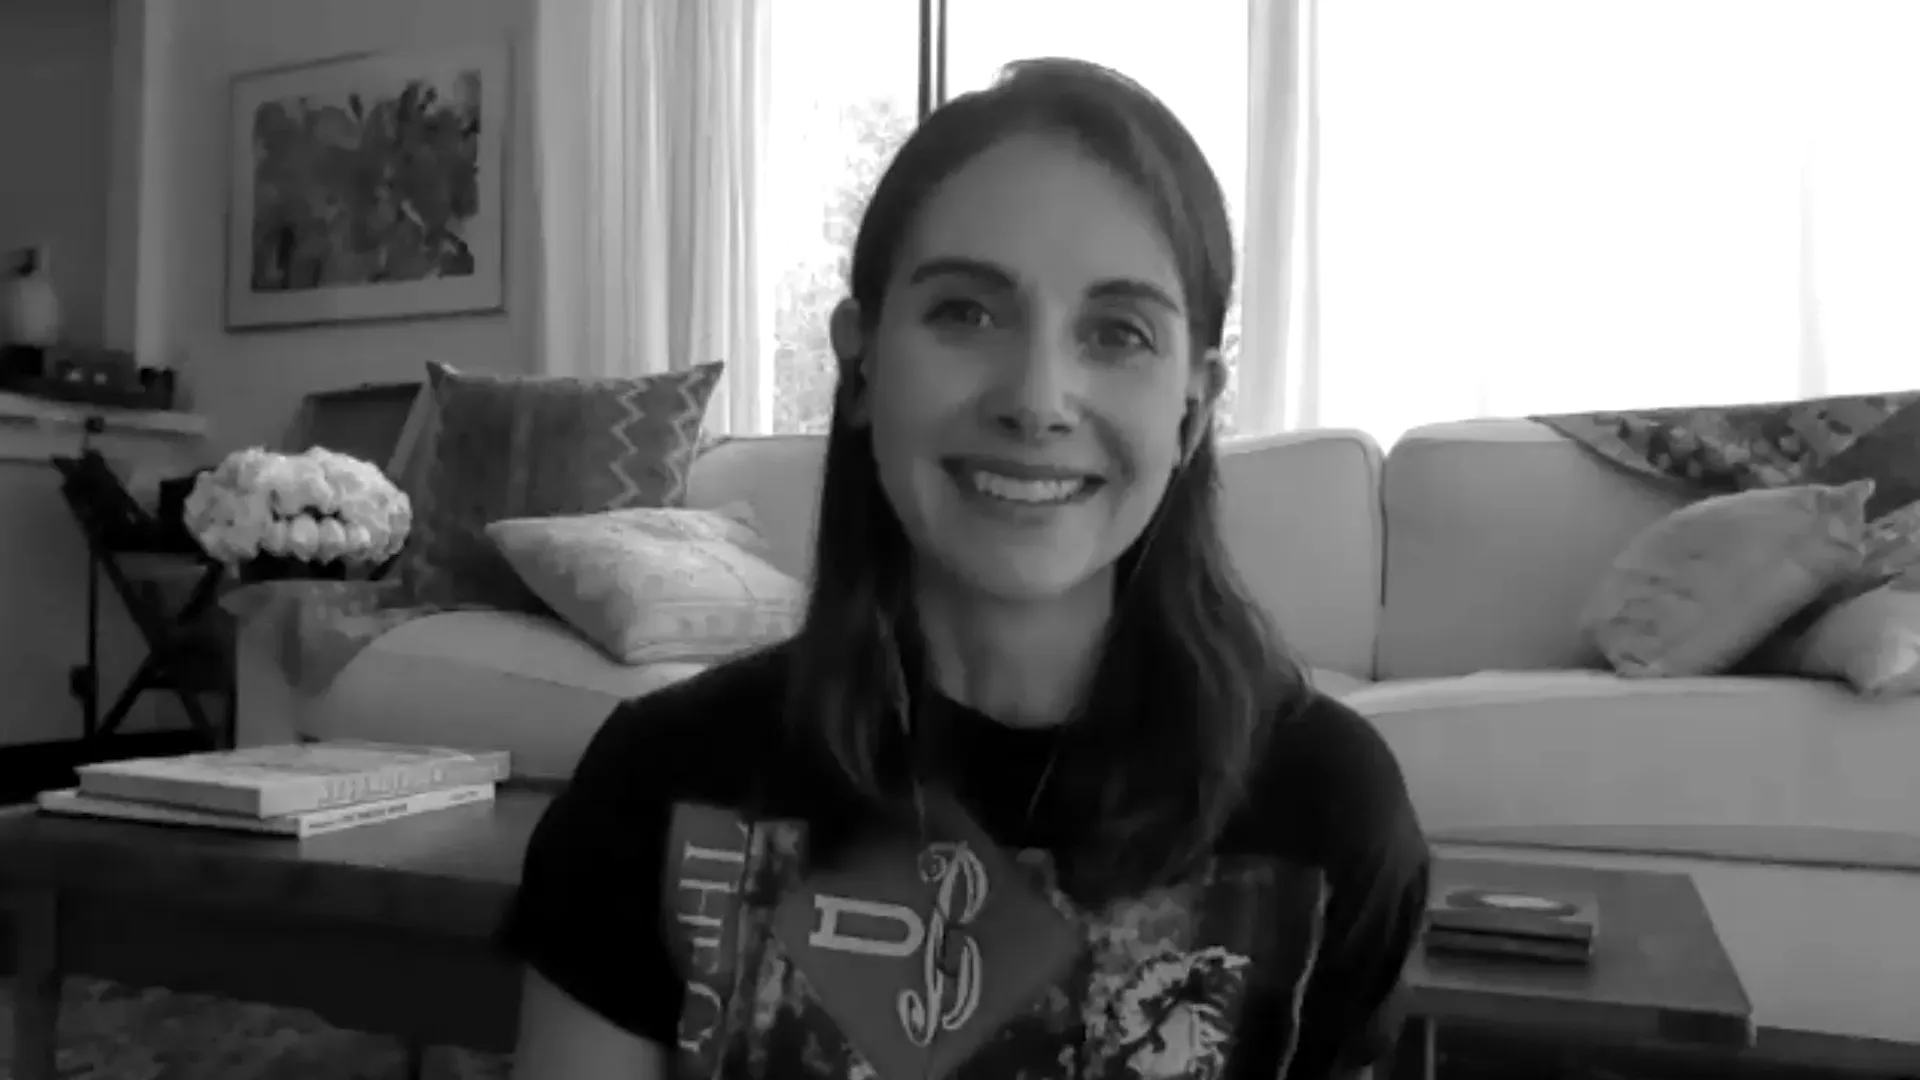Describe the mood of this image. The mood of this image is warmly inviting, creating a sense of coziness and relaxation. The woman’s friendly smile and casual attire in the comfort of her tastefully decorated living room evoke feelings of ease and charm. The natural light pouring in through the window adds to the serene and welcoming atmosphere. 